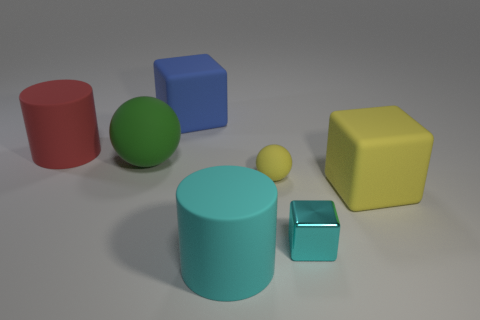Is there anything else that is made of the same material as the tiny cube?
Offer a very short reply. No. The cyan object that is made of the same material as the large blue thing is what size?
Ensure brevity in your answer.  Large. What size is the yellow matte sphere?
Your response must be concise. Small. Are the big red thing and the yellow sphere made of the same material?
Ensure brevity in your answer.  Yes. What number of spheres are either big red matte objects or cyan metal things?
Give a very brief answer. 0. The cylinder that is to the left of the big matte thing that is behind the big red cylinder is what color?
Offer a terse response. Red. What size is the other rubber thing that is the same color as the tiny rubber thing?
Offer a terse response. Large. There is a matte block behind the big matte cylinder that is behind the cyan matte object; how many small matte spheres are right of it?
Offer a terse response. 1. There is a cyan object that is to the right of the yellow sphere; is its shape the same as the tiny object behind the big yellow matte cube?
Your answer should be compact. No. What number of objects are either large green things or big brown metal balls?
Keep it short and to the point. 1. 